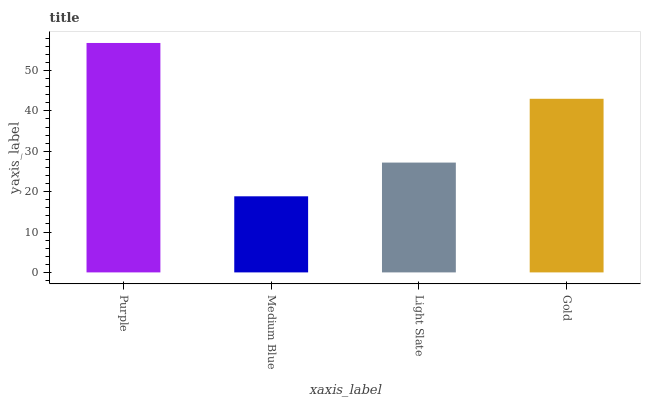Is Medium Blue the minimum?
Answer yes or no. Yes. Is Purple the maximum?
Answer yes or no. Yes. Is Light Slate the minimum?
Answer yes or no. No. Is Light Slate the maximum?
Answer yes or no. No. Is Light Slate greater than Medium Blue?
Answer yes or no. Yes. Is Medium Blue less than Light Slate?
Answer yes or no. Yes. Is Medium Blue greater than Light Slate?
Answer yes or no. No. Is Light Slate less than Medium Blue?
Answer yes or no. No. Is Gold the high median?
Answer yes or no. Yes. Is Light Slate the low median?
Answer yes or no. Yes. Is Light Slate the high median?
Answer yes or no. No. Is Purple the low median?
Answer yes or no. No. 